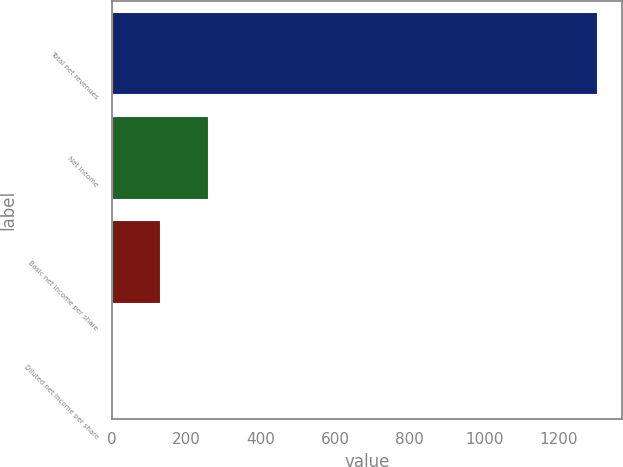Convert chart to OTSL. <chart><loc_0><loc_0><loc_500><loc_500><bar_chart><fcel>Total net revenues<fcel>Net income<fcel>Basic net income per share<fcel>Diluted net income per share<nl><fcel>1304.6<fcel>261.6<fcel>131.22<fcel>0.84<nl></chart> 